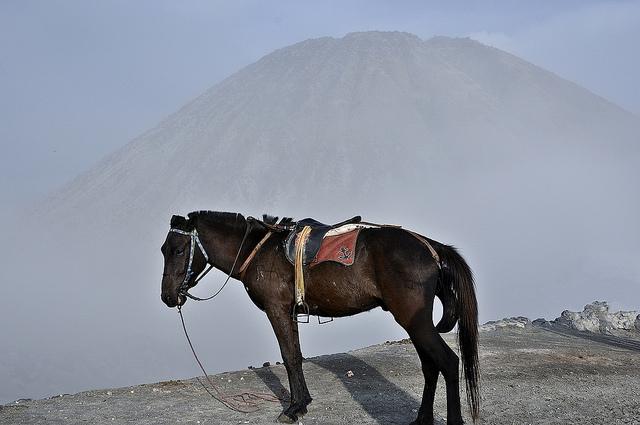What breed of horse is this?
Concise answer only. Don't know. Is this horse wearing a saddle?
Be succinct. Yes. Are there more than one horse?
Concise answer only. No. 